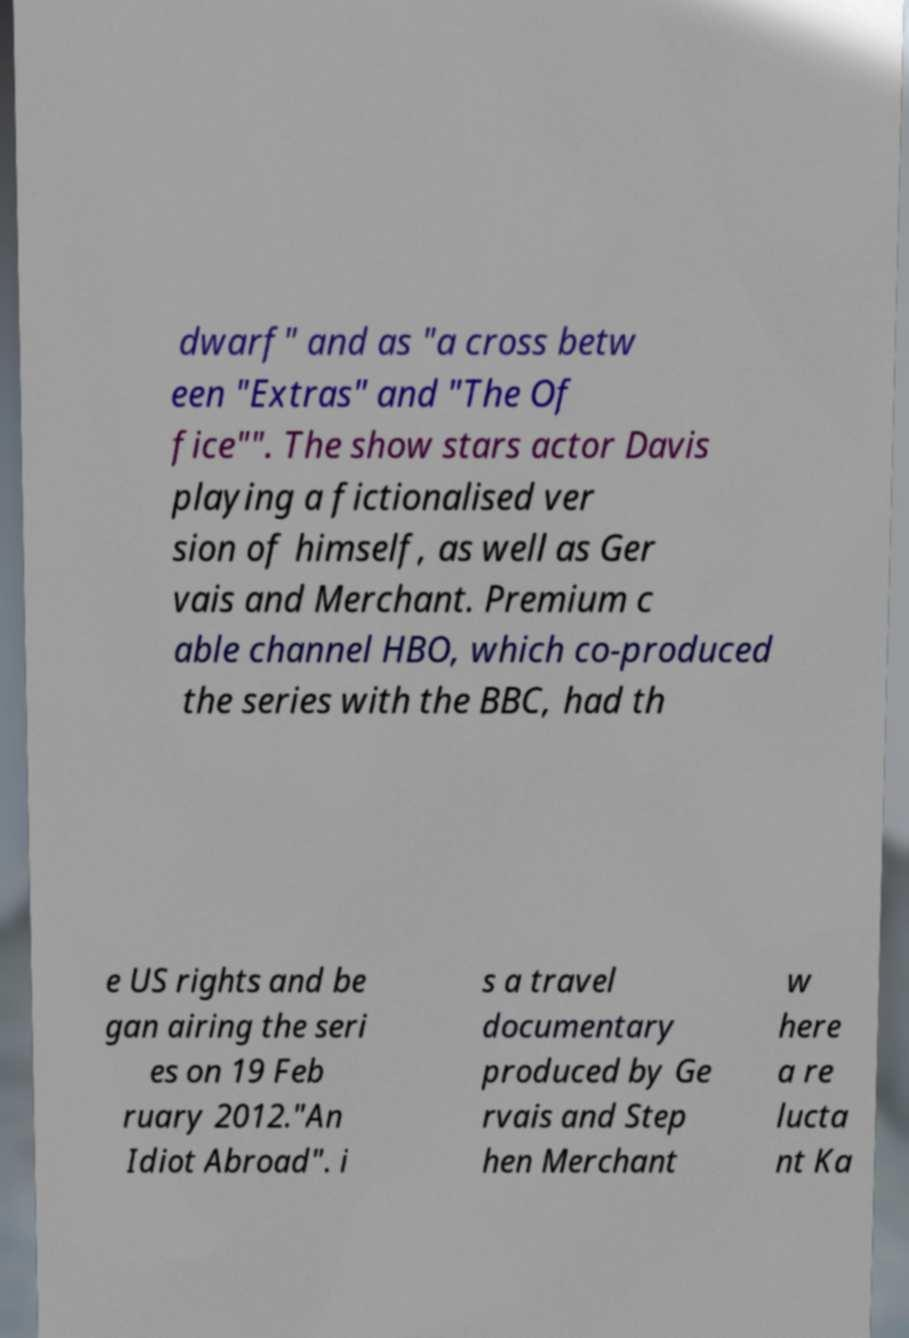Can you accurately transcribe the text from the provided image for me? dwarf" and as "a cross betw een "Extras" and "The Of fice"". The show stars actor Davis playing a fictionalised ver sion of himself, as well as Ger vais and Merchant. Premium c able channel HBO, which co-produced the series with the BBC, had th e US rights and be gan airing the seri es on 19 Feb ruary 2012."An Idiot Abroad". i s a travel documentary produced by Ge rvais and Step hen Merchant w here a re lucta nt Ka 